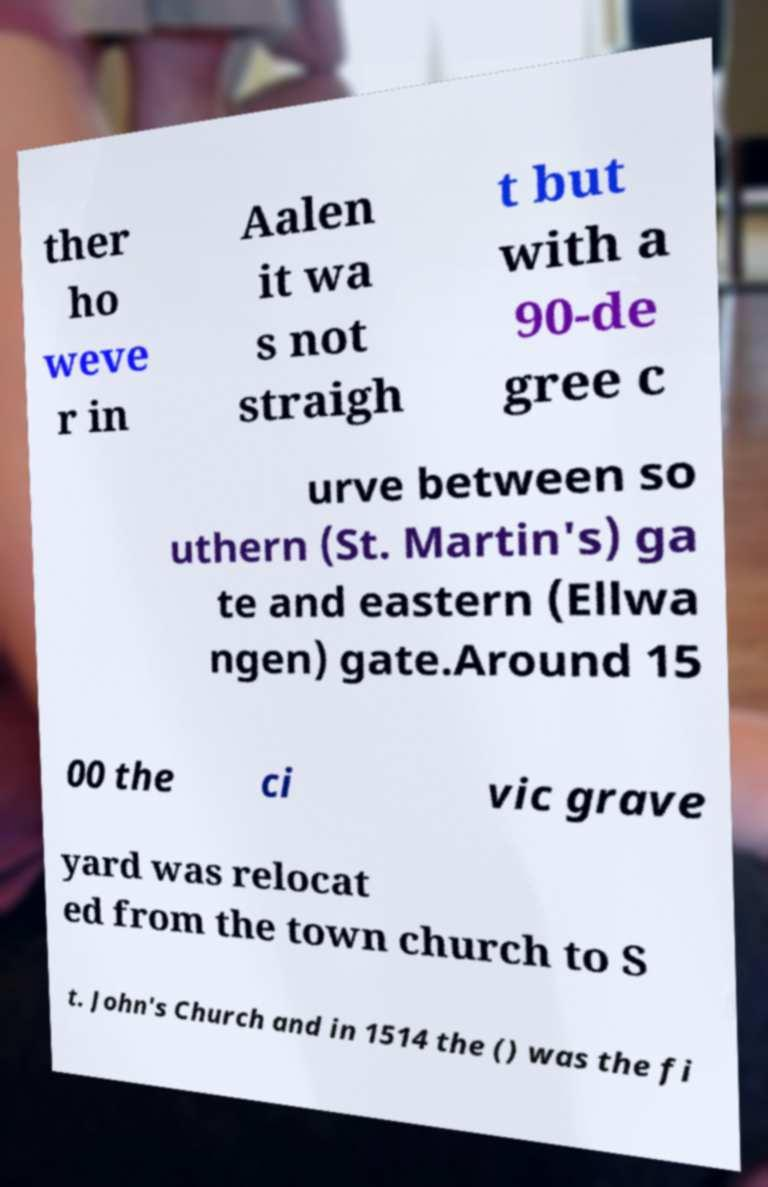What messages or text are displayed in this image? I need them in a readable, typed format. ther ho weve r in Aalen it wa s not straigh t but with a 90-de gree c urve between so uthern (St. Martin's) ga te and eastern (Ellwa ngen) gate.Around 15 00 the ci vic grave yard was relocat ed from the town church to S t. John's Church and in 1514 the () was the fi 